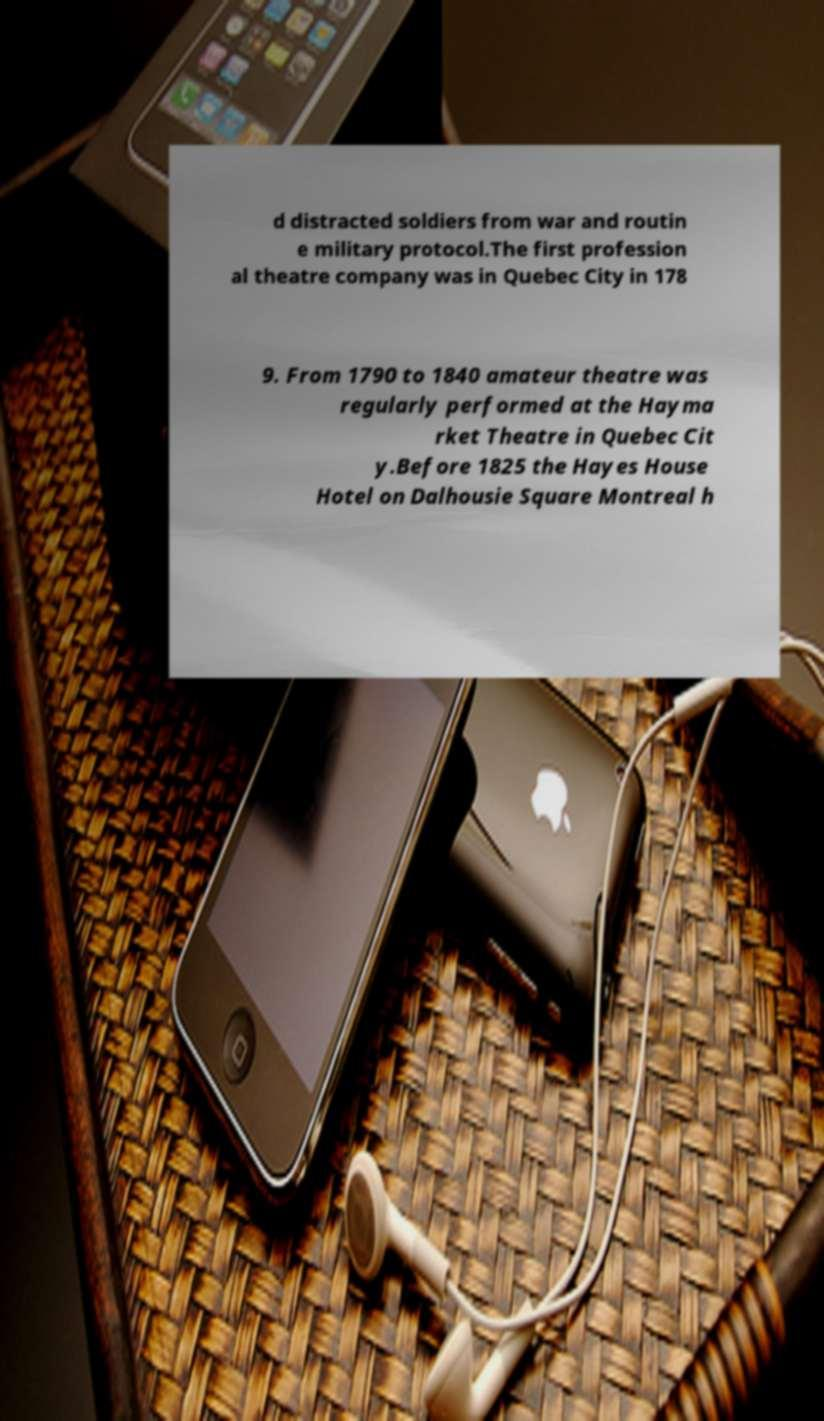Could you extract and type out the text from this image? d distracted soldiers from war and routin e military protocol.The first profession al theatre company was in Quebec City in 178 9. From 1790 to 1840 amateur theatre was regularly performed at the Hayma rket Theatre in Quebec Cit y.Before 1825 the Hayes House Hotel on Dalhousie Square Montreal h 